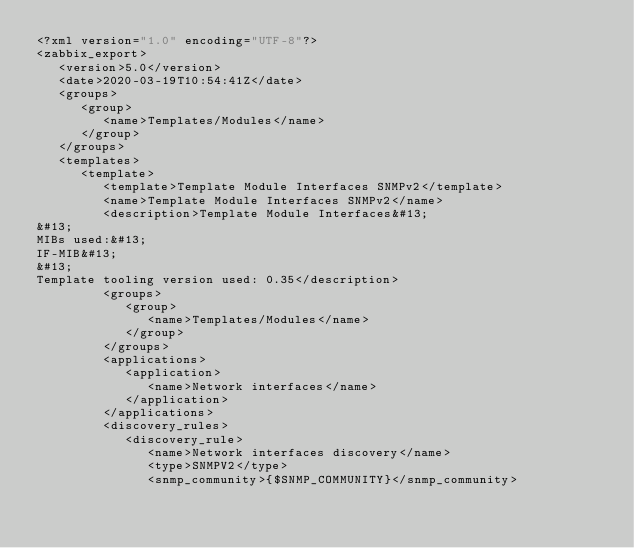Convert code to text. <code><loc_0><loc_0><loc_500><loc_500><_XML_><?xml version="1.0" encoding="UTF-8"?>
<zabbix_export>
   <version>5.0</version>
   <date>2020-03-19T10:54:41Z</date>
   <groups>
      <group>
         <name>Templates/Modules</name>
      </group>
   </groups>
   <templates>
      <template>
         <template>Template Module Interfaces SNMPv2</template>
         <name>Template Module Interfaces SNMPv2</name>
         <description>Template Module Interfaces&#13;
&#13;
MIBs used:&#13;
IF-MIB&#13;
&#13;
Template tooling version used: 0.35</description>
         <groups>
            <group>
               <name>Templates/Modules</name>
            </group>
         </groups>
         <applications>
            <application>
               <name>Network interfaces</name>
            </application>
         </applications>
         <discovery_rules>
            <discovery_rule>
               <name>Network interfaces discovery</name>
               <type>SNMPV2</type>
               <snmp_community>{$SNMP_COMMUNITY}</snmp_community></code> 